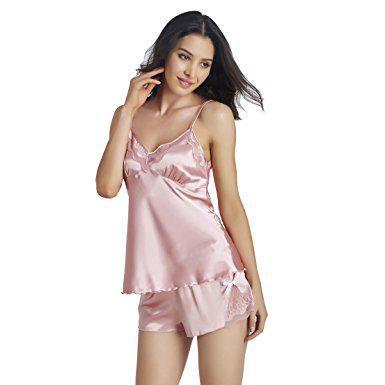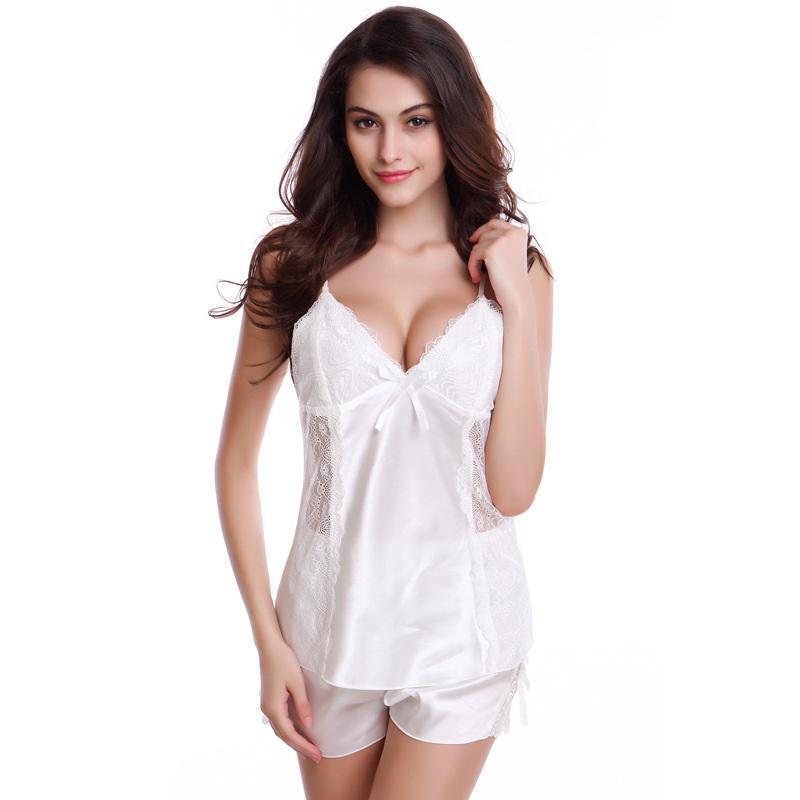The first image is the image on the left, the second image is the image on the right. Examine the images to the left and right. Is the description "One model is wearing a shiny pink matching camisole top and short shorts." accurate? Answer yes or no. Yes. The first image is the image on the left, the second image is the image on the right. Evaluate the accuracy of this statement regarding the images: "A woman is wearing a silky shiny pink sleepwear.". Is it true? Answer yes or no. Yes. 